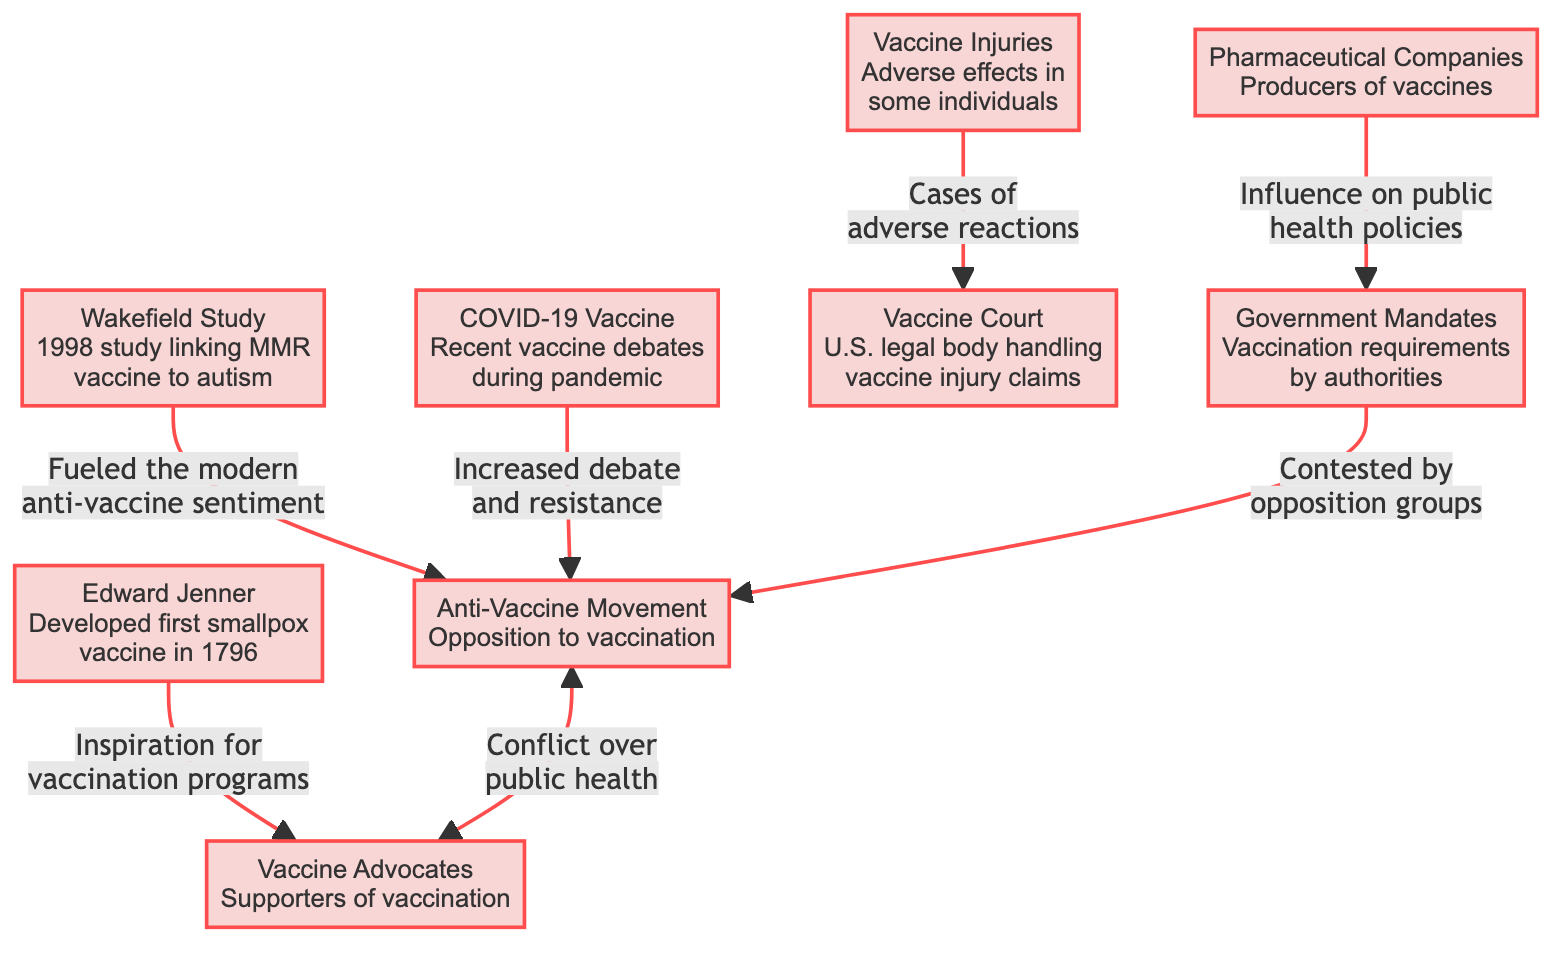What event did Edward Jenner develop in 1796? Edward Jenner developed the first smallpox vaccine in 1796, as indicated by the information in the node labeled "Edward Jenner."
Answer: first smallpox vaccine How did the Wakefield Study impact public perception of vaccines? The Wakefield Study is linked to the fueling of modern anti-vaccine sentiment, as described in the connection to the Anti-Vaccine Movement.
Answer: fueled modern anti-vaccine sentiment What issues does the Vaccine Court handle? The Vaccine Court handles vaccine injury claims, as stated in the node labeled "Vaccine Court."
Answer: vaccine injury claims Which stakeholders are influenced by pharmaceutical companies? Pharmaceutical companies influence government mandates concerning vaccination requirements, as identified in the connection from the Pharmaceutical Companies node.
Answer: government mandates What recent vaccine debates are mentioned in the diagram? The COVID-19 Vaccine node mentions recent vaccine debates during the pandemic, signifying the ongoing discussions about vaccines in that context.
Answer: COVID-19 Vaccine What type of conflict is shown between the Anti-Vaccine Movement and Vaccine Advocates? The diagram indicates a conflict over public health between the Anti-Vaccine Movement and Vaccine Advocates, reflecting the opposing views of these groups.
Answer: conflict over public health How many main historical events and stakeholders are represented in the diagram? The diagram features eight main nodes listing historical events and stakeholders like Edward Jenner, the Wakefield Study, and others, totaling eight.
Answer: eight What is one outcome associated with adverse vaccine reactions? The node detailing Vaccine Injuries connects to the Vaccine Court, indicating that claims of adverse reactions can lead to legal proceedings.
Answer: Vaccine Court Which group contests government vaccination mandates? The Anti-Vaccine Movement is the group that contests government mandates regarding vaccinations, as shown in the linking arrows in the diagram.
Answer: Anti-Vaccine Movement 